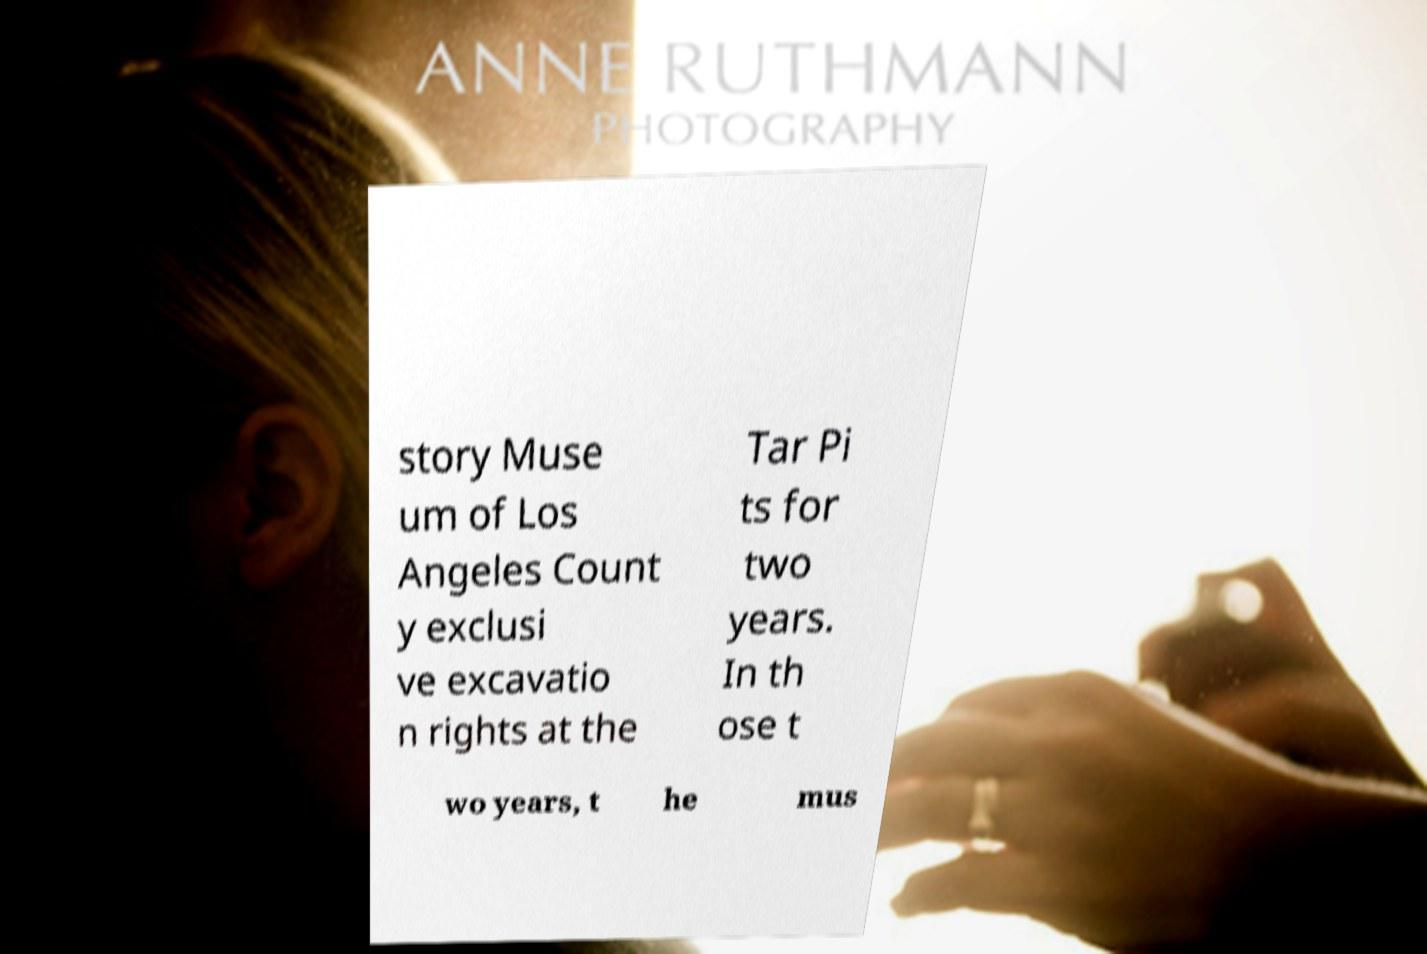For documentation purposes, I need the text within this image transcribed. Could you provide that? story Muse um of Los Angeles Count y exclusi ve excavatio n rights at the Tar Pi ts for two years. In th ose t wo years, t he mus 